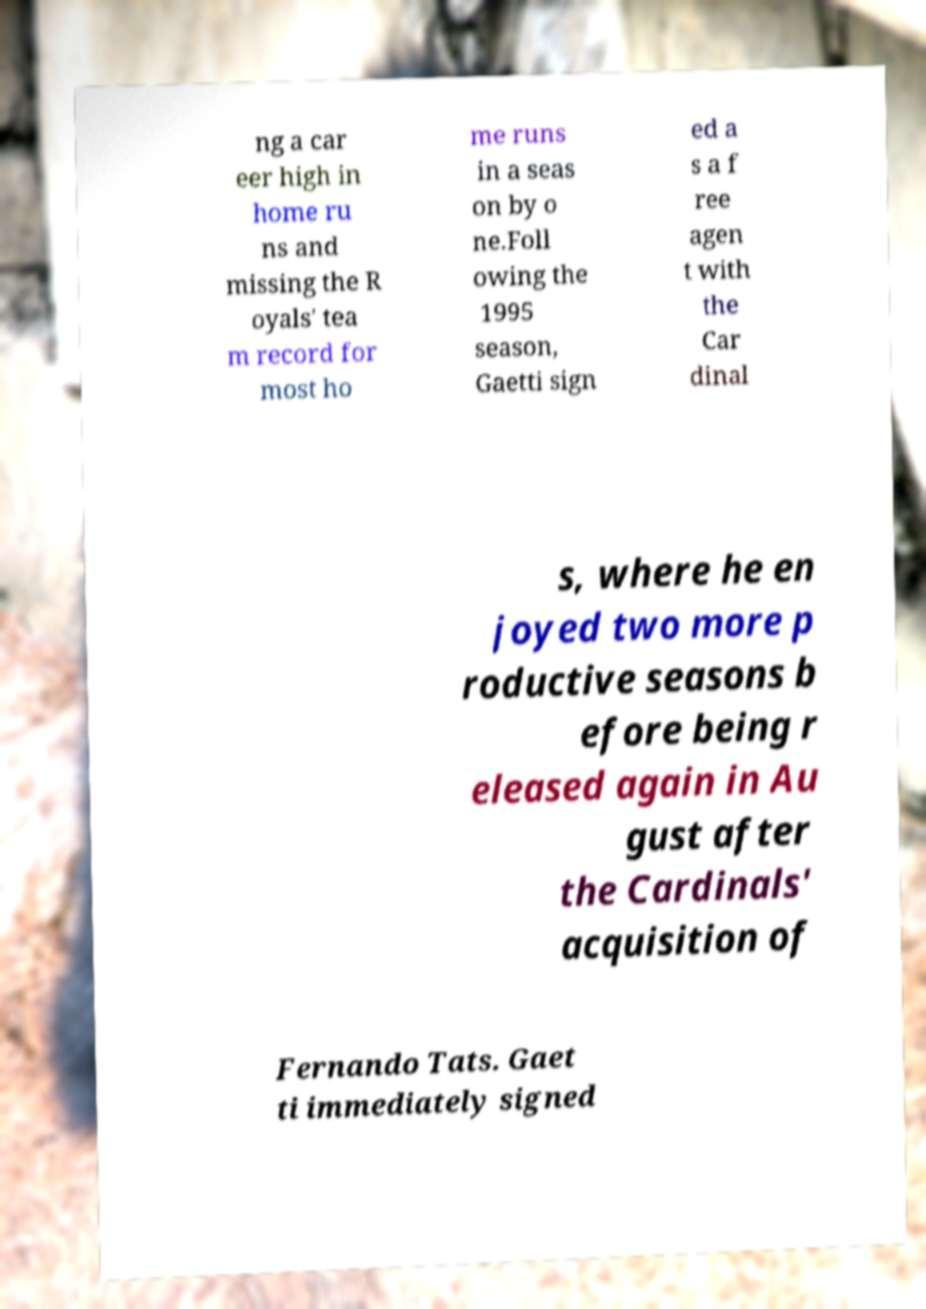Could you assist in decoding the text presented in this image and type it out clearly? ng a car eer high in home ru ns and missing the R oyals' tea m record for most ho me runs in a seas on by o ne.Foll owing the 1995 season, Gaetti sign ed a s a f ree agen t with the Car dinal s, where he en joyed two more p roductive seasons b efore being r eleased again in Au gust after the Cardinals' acquisition of Fernando Tats. Gaet ti immediately signed 